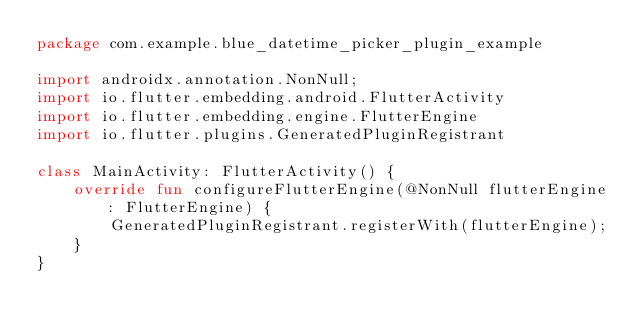Convert code to text. <code><loc_0><loc_0><loc_500><loc_500><_Kotlin_>package com.example.blue_datetime_picker_plugin_example

import androidx.annotation.NonNull;
import io.flutter.embedding.android.FlutterActivity
import io.flutter.embedding.engine.FlutterEngine
import io.flutter.plugins.GeneratedPluginRegistrant

class MainActivity: FlutterActivity() {
    override fun configureFlutterEngine(@NonNull flutterEngine: FlutterEngine) {
        GeneratedPluginRegistrant.registerWith(flutterEngine);
    }
}
</code> 